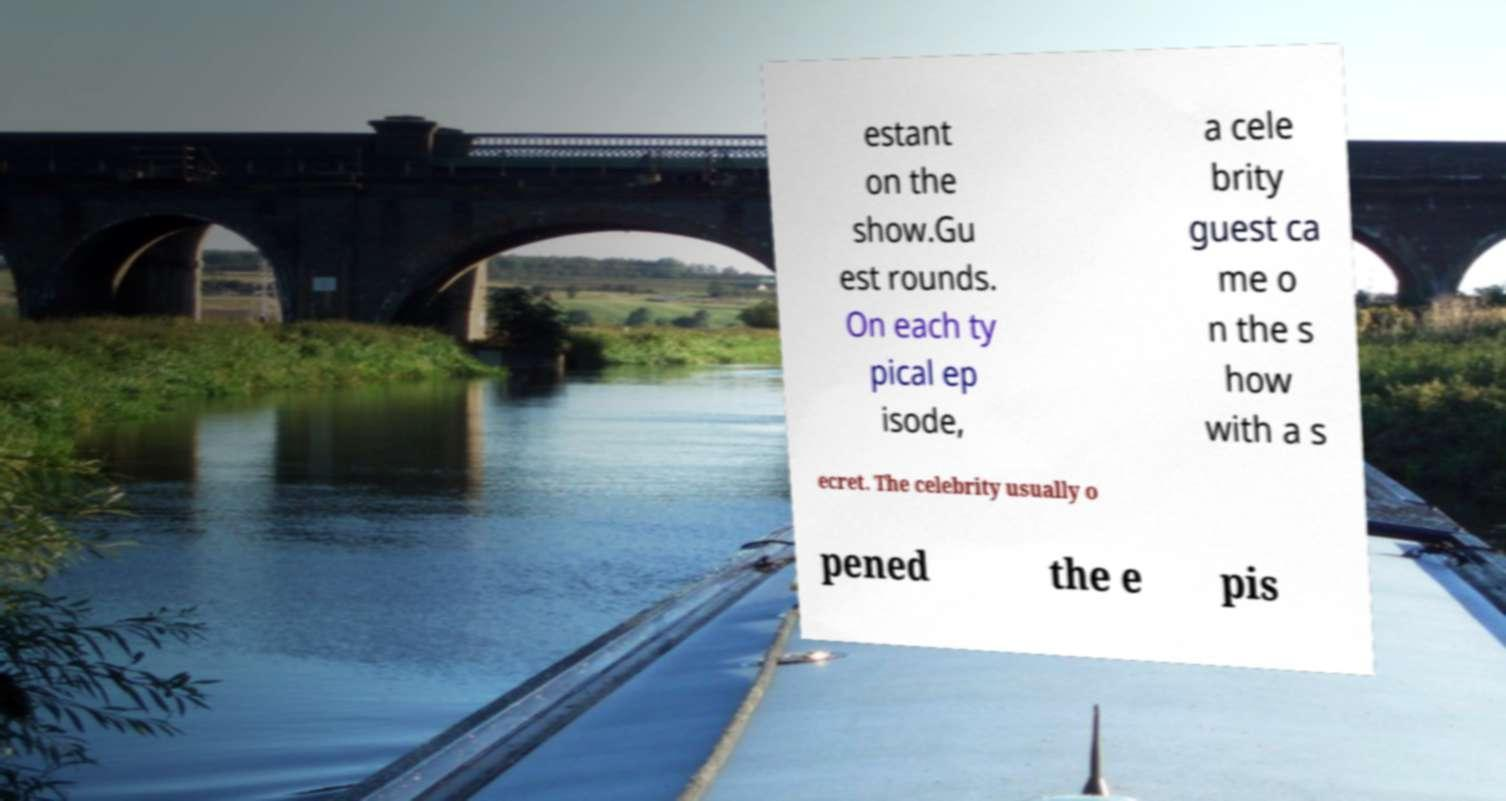Please read and relay the text visible in this image. What does it say? estant on the show.Gu est rounds. On each ty pical ep isode, a cele brity guest ca me o n the s how with a s ecret. The celebrity usually o pened the e pis 